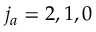Convert formula to latex. <formula><loc_0><loc_0><loc_500><loc_500>{ j _ { a } } = 2 , 1 , 0</formula> 